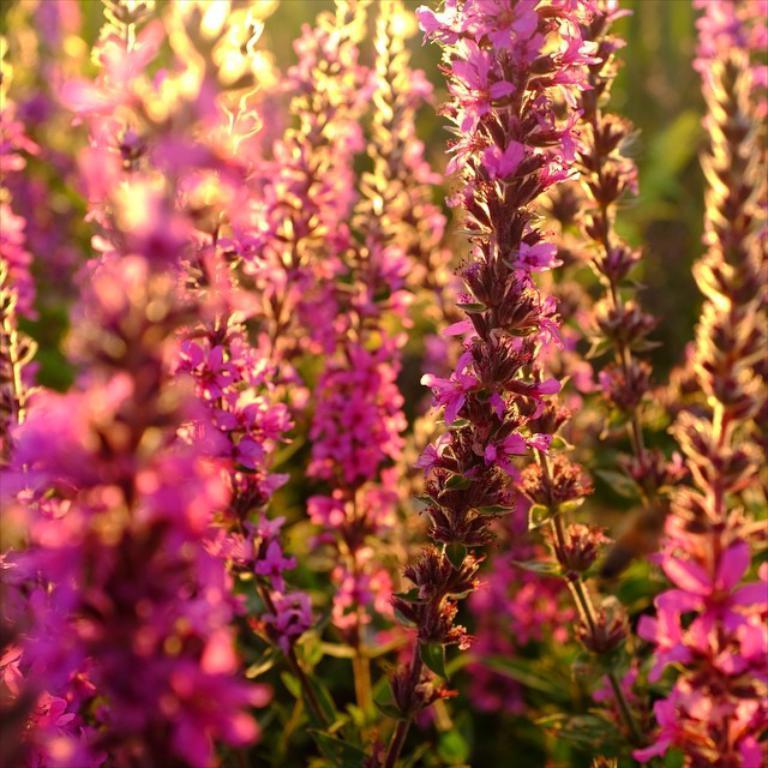Describe this image in one or two sentences. In this image I can see flowers in pink color, background I can see plants in green color. 